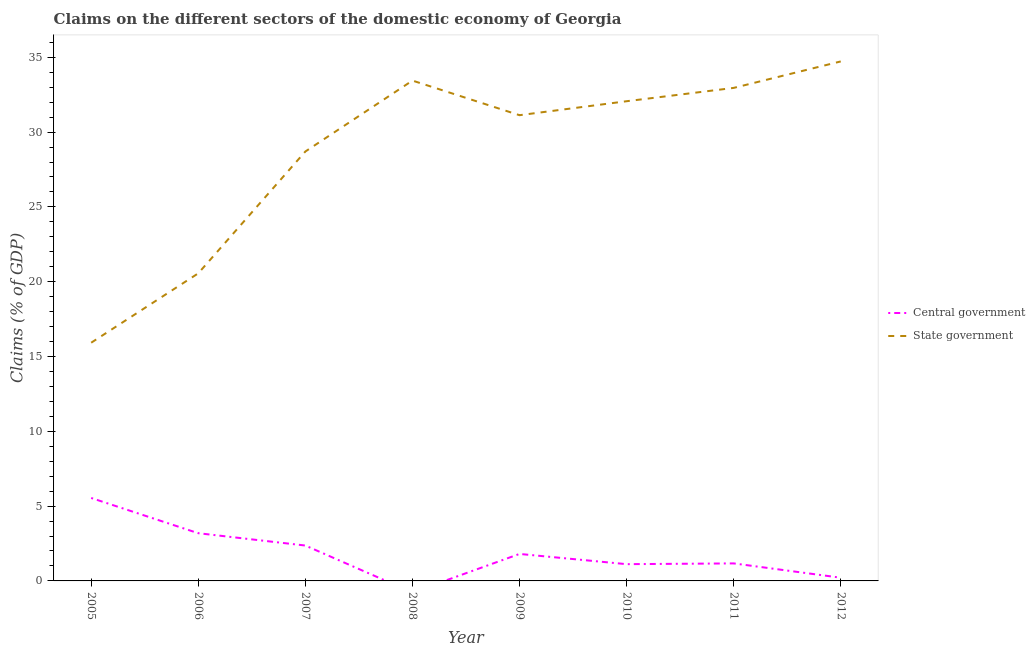How many different coloured lines are there?
Offer a very short reply. 2. Does the line corresponding to claims on central government intersect with the line corresponding to claims on state government?
Provide a succinct answer. No. Is the number of lines equal to the number of legend labels?
Keep it short and to the point. No. What is the claims on state government in 2006?
Keep it short and to the point. 20.56. Across all years, what is the maximum claims on central government?
Your answer should be very brief. 5.54. In which year was the claims on state government maximum?
Provide a short and direct response. 2012. What is the total claims on central government in the graph?
Make the answer very short. 15.41. What is the difference between the claims on central government in 2006 and that in 2010?
Your answer should be compact. 2.07. What is the difference between the claims on central government in 2009 and the claims on state government in 2007?
Make the answer very short. -26.9. What is the average claims on state government per year?
Your answer should be compact. 28.69. In the year 2009, what is the difference between the claims on state government and claims on central government?
Provide a succinct answer. 29.33. In how many years, is the claims on central government greater than 19 %?
Offer a terse response. 0. What is the ratio of the claims on state government in 2005 to that in 2011?
Give a very brief answer. 0.48. Is the difference between the claims on state government in 2006 and 2011 greater than the difference between the claims on central government in 2006 and 2011?
Give a very brief answer. No. What is the difference between the highest and the second highest claims on state government?
Give a very brief answer. 1.28. What is the difference between the highest and the lowest claims on state government?
Keep it short and to the point. 18.8. Does the claims on state government monotonically increase over the years?
Your answer should be compact. No. Is the claims on state government strictly greater than the claims on central government over the years?
Offer a very short reply. Yes. Is the claims on state government strictly less than the claims on central government over the years?
Give a very brief answer. No. How many lines are there?
Give a very brief answer. 2. How many years are there in the graph?
Provide a succinct answer. 8. Does the graph contain any zero values?
Your response must be concise. Yes. Does the graph contain grids?
Make the answer very short. No. How are the legend labels stacked?
Your answer should be very brief. Vertical. What is the title of the graph?
Your response must be concise. Claims on the different sectors of the domestic economy of Georgia. What is the label or title of the Y-axis?
Offer a very short reply. Claims (% of GDP). What is the Claims (% of GDP) in Central government in 2005?
Offer a terse response. 5.54. What is the Claims (% of GDP) in State government in 2005?
Give a very brief answer. 15.92. What is the Claims (% of GDP) of Central government in 2006?
Your answer should be compact. 3.19. What is the Claims (% of GDP) in State government in 2006?
Ensure brevity in your answer.  20.56. What is the Claims (% of GDP) in Central government in 2007?
Keep it short and to the point. 2.37. What is the Claims (% of GDP) of State government in 2007?
Provide a short and direct response. 28.7. What is the Claims (% of GDP) of State government in 2008?
Your answer should be very brief. 33.44. What is the Claims (% of GDP) of Central government in 2009?
Offer a very short reply. 1.8. What is the Claims (% of GDP) of State government in 2009?
Your answer should be very brief. 31.13. What is the Claims (% of GDP) of Central government in 2010?
Provide a succinct answer. 1.12. What is the Claims (% of GDP) of State government in 2010?
Offer a very short reply. 32.06. What is the Claims (% of GDP) of Central government in 2011?
Your answer should be very brief. 1.17. What is the Claims (% of GDP) of State government in 2011?
Keep it short and to the point. 32.95. What is the Claims (% of GDP) in Central government in 2012?
Provide a short and direct response. 0.21. What is the Claims (% of GDP) of State government in 2012?
Ensure brevity in your answer.  34.72. Across all years, what is the maximum Claims (% of GDP) in Central government?
Your response must be concise. 5.54. Across all years, what is the maximum Claims (% of GDP) in State government?
Keep it short and to the point. 34.72. Across all years, what is the minimum Claims (% of GDP) in State government?
Make the answer very short. 15.92. What is the total Claims (% of GDP) of Central government in the graph?
Your response must be concise. 15.41. What is the total Claims (% of GDP) of State government in the graph?
Provide a short and direct response. 229.49. What is the difference between the Claims (% of GDP) in Central government in 2005 and that in 2006?
Provide a short and direct response. 2.35. What is the difference between the Claims (% of GDP) in State government in 2005 and that in 2006?
Offer a very short reply. -4.64. What is the difference between the Claims (% of GDP) of Central government in 2005 and that in 2007?
Give a very brief answer. 3.18. What is the difference between the Claims (% of GDP) of State government in 2005 and that in 2007?
Provide a short and direct response. -12.78. What is the difference between the Claims (% of GDP) of State government in 2005 and that in 2008?
Your answer should be compact. -17.52. What is the difference between the Claims (% of GDP) of Central government in 2005 and that in 2009?
Provide a succinct answer. 3.74. What is the difference between the Claims (% of GDP) in State government in 2005 and that in 2009?
Your response must be concise. -15.21. What is the difference between the Claims (% of GDP) of Central government in 2005 and that in 2010?
Give a very brief answer. 4.42. What is the difference between the Claims (% of GDP) in State government in 2005 and that in 2010?
Make the answer very short. -16.14. What is the difference between the Claims (% of GDP) of Central government in 2005 and that in 2011?
Your answer should be very brief. 4.37. What is the difference between the Claims (% of GDP) in State government in 2005 and that in 2011?
Give a very brief answer. -17.03. What is the difference between the Claims (% of GDP) of Central government in 2005 and that in 2012?
Your answer should be compact. 5.33. What is the difference between the Claims (% of GDP) of State government in 2005 and that in 2012?
Give a very brief answer. -18.8. What is the difference between the Claims (% of GDP) of Central government in 2006 and that in 2007?
Make the answer very short. 0.82. What is the difference between the Claims (% of GDP) of State government in 2006 and that in 2007?
Provide a succinct answer. -8.14. What is the difference between the Claims (% of GDP) in State government in 2006 and that in 2008?
Your response must be concise. -12.88. What is the difference between the Claims (% of GDP) of Central government in 2006 and that in 2009?
Your answer should be compact. 1.39. What is the difference between the Claims (% of GDP) of State government in 2006 and that in 2009?
Give a very brief answer. -10.57. What is the difference between the Claims (% of GDP) of Central government in 2006 and that in 2010?
Keep it short and to the point. 2.07. What is the difference between the Claims (% of GDP) of State government in 2006 and that in 2010?
Provide a succinct answer. -11.5. What is the difference between the Claims (% of GDP) in Central government in 2006 and that in 2011?
Ensure brevity in your answer.  2.02. What is the difference between the Claims (% of GDP) of State government in 2006 and that in 2011?
Ensure brevity in your answer.  -12.39. What is the difference between the Claims (% of GDP) in Central government in 2006 and that in 2012?
Ensure brevity in your answer.  2.97. What is the difference between the Claims (% of GDP) of State government in 2006 and that in 2012?
Offer a terse response. -14.16. What is the difference between the Claims (% of GDP) in State government in 2007 and that in 2008?
Ensure brevity in your answer.  -4.74. What is the difference between the Claims (% of GDP) of Central government in 2007 and that in 2009?
Give a very brief answer. 0.56. What is the difference between the Claims (% of GDP) in State government in 2007 and that in 2009?
Offer a very short reply. -2.43. What is the difference between the Claims (% of GDP) in Central government in 2007 and that in 2010?
Offer a very short reply. 1.25. What is the difference between the Claims (% of GDP) in State government in 2007 and that in 2010?
Your answer should be compact. -3.36. What is the difference between the Claims (% of GDP) of Central government in 2007 and that in 2011?
Your answer should be very brief. 1.19. What is the difference between the Claims (% of GDP) of State government in 2007 and that in 2011?
Your response must be concise. -4.25. What is the difference between the Claims (% of GDP) of Central government in 2007 and that in 2012?
Your answer should be compact. 2.15. What is the difference between the Claims (% of GDP) of State government in 2007 and that in 2012?
Make the answer very short. -6.02. What is the difference between the Claims (% of GDP) of State government in 2008 and that in 2009?
Your response must be concise. 2.31. What is the difference between the Claims (% of GDP) of State government in 2008 and that in 2010?
Keep it short and to the point. 1.38. What is the difference between the Claims (% of GDP) in State government in 2008 and that in 2011?
Offer a very short reply. 0.49. What is the difference between the Claims (% of GDP) of State government in 2008 and that in 2012?
Provide a short and direct response. -1.28. What is the difference between the Claims (% of GDP) of Central government in 2009 and that in 2010?
Ensure brevity in your answer.  0.68. What is the difference between the Claims (% of GDP) in State government in 2009 and that in 2010?
Keep it short and to the point. -0.93. What is the difference between the Claims (% of GDP) in Central government in 2009 and that in 2011?
Offer a very short reply. 0.63. What is the difference between the Claims (% of GDP) in State government in 2009 and that in 2011?
Offer a terse response. -1.82. What is the difference between the Claims (% of GDP) in Central government in 2009 and that in 2012?
Provide a short and direct response. 1.59. What is the difference between the Claims (% of GDP) of State government in 2009 and that in 2012?
Your answer should be compact. -3.59. What is the difference between the Claims (% of GDP) in Central government in 2010 and that in 2011?
Offer a terse response. -0.05. What is the difference between the Claims (% of GDP) in State government in 2010 and that in 2011?
Offer a very short reply. -0.89. What is the difference between the Claims (% of GDP) of Central government in 2010 and that in 2012?
Keep it short and to the point. 0.91. What is the difference between the Claims (% of GDP) of State government in 2010 and that in 2012?
Your answer should be very brief. -2.66. What is the difference between the Claims (% of GDP) of Central government in 2011 and that in 2012?
Offer a very short reply. 0.96. What is the difference between the Claims (% of GDP) of State government in 2011 and that in 2012?
Ensure brevity in your answer.  -1.77. What is the difference between the Claims (% of GDP) of Central government in 2005 and the Claims (% of GDP) of State government in 2006?
Offer a very short reply. -15.02. What is the difference between the Claims (% of GDP) in Central government in 2005 and the Claims (% of GDP) in State government in 2007?
Your response must be concise. -23.16. What is the difference between the Claims (% of GDP) of Central government in 2005 and the Claims (% of GDP) of State government in 2008?
Keep it short and to the point. -27.9. What is the difference between the Claims (% of GDP) in Central government in 2005 and the Claims (% of GDP) in State government in 2009?
Your answer should be very brief. -25.59. What is the difference between the Claims (% of GDP) in Central government in 2005 and the Claims (% of GDP) in State government in 2010?
Provide a short and direct response. -26.52. What is the difference between the Claims (% of GDP) in Central government in 2005 and the Claims (% of GDP) in State government in 2011?
Your answer should be compact. -27.41. What is the difference between the Claims (% of GDP) of Central government in 2005 and the Claims (% of GDP) of State government in 2012?
Ensure brevity in your answer.  -29.18. What is the difference between the Claims (% of GDP) in Central government in 2006 and the Claims (% of GDP) in State government in 2007?
Your answer should be compact. -25.51. What is the difference between the Claims (% of GDP) in Central government in 2006 and the Claims (% of GDP) in State government in 2008?
Offer a terse response. -30.25. What is the difference between the Claims (% of GDP) of Central government in 2006 and the Claims (% of GDP) of State government in 2009?
Your response must be concise. -27.94. What is the difference between the Claims (% of GDP) in Central government in 2006 and the Claims (% of GDP) in State government in 2010?
Keep it short and to the point. -28.87. What is the difference between the Claims (% of GDP) in Central government in 2006 and the Claims (% of GDP) in State government in 2011?
Offer a very short reply. -29.76. What is the difference between the Claims (% of GDP) of Central government in 2006 and the Claims (% of GDP) of State government in 2012?
Provide a succinct answer. -31.53. What is the difference between the Claims (% of GDP) in Central government in 2007 and the Claims (% of GDP) in State government in 2008?
Your response must be concise. -31.08. What is the difference between the Claims (% of GDP) in Central government in 2007 and the Claims (% of GDP) in State government in 2009?
Provide a short and direct response. -28.76. What is the difference between the Claims (% of GDP) of Central government in 2007 and the Claims (% of GDP) of State government in 2010?
Give a very brief answer. -29.7. What is the difference between the Claims (% of GDP) of Central government in 2007 and the Claims (% of GDP) of State government in 2011?
Offer a terse response. -30.59. What is the difference between the Claims (% of GDP) in Central government in 2007 and the Claims (% of GDP) in State government in 2012?
Your answer should be compact. -32.36. What is the difference between the Claims (% of GDP) in Central government in 2009 and the Claims (% of GDP) in State government in 2010?
Give a very brief answer. -30.26. What is the difference between the Claims (% of GDP) of Central government in 2009 and the Claims (% of GDP) of State government in 2011?
Your response must be concise. -31.15. What is the difference between the Claims (% of GDP) of Central government in 2009 and the Claims (% of GDP) of State government in 2012?
Your answer should be very brief. -32.92. What is the difference between the Claims (% of GDP) of Central government in 2010 and the Claims (% of GDP) of State government in 2011?
Make the answer very short. -31.83. What is the difference between the Claims (% of GDP) in Central government in 2010 and the Claims (% of GDP) in State government in 2012?
Offer a very short reply. -33.6. What is the difference between the Claims (% of GDP) of Central government in 2011 and the Claims (% of GDP) of State government in 2012?
Keep it short and to the point. -33.55. What is the average Claims (% of GDP) of Central government per year?
Keep it short and to the point. 1.93. What is the average Claims (% of GDP) of State government per year?
Keep it short and to the point. 28.69. In the year 2005, what is the difference between the Claims (% of GDP) of Central government and Claims (% of GDP) of State government?
Your answer should be compact. -10.38. In the year 2006, what is the difference between the Claims (% of GDP) in Central government and Claims (% of GDP) in State government?
Offer a terse response. -17.37. In the year 2007, what is the difference between the Claims (% of GDP) in Central government and Claims (% of GDP) in State government?
Your response must be concise. -26.34. In the year 2009, what is the difference between the Claims (% of GDP) in Central government and Claims (% of GDP) in State government?
Your response must be concise. -29.33. In the year 2010, what is the difference between the Claims (% of GDP) in Central government and Claims (% of GDP) in State government?
Keep it short and to the point. -30.94. In the year 2011, what is the difference between the Claims (% of GDP) in Central government and Claims (% of GDP) in State government?
Provide a short and direct response. -31.78. In the year 2012, what is the difference between the Claims (% of GDP) in Central government and Claims (% of GDP) in State government?
Your answer should be compact. -34.51. What is the ratio of the Claims (% of GDP) of Central government in 2005 to that in 2006?
Offer a terse response. 1.74. What is the ratio of the Claims (% of GDP) in State government in 2005 to that in 2006?
Your answer should be compact. 0.77. What is the ratio of the Claims (% of GDP) in Central government in 2005 to that in 2007?
Provide a short and direct response. 2.34. What is the ratio of the Claims (% of GDP) of State government in 2005 to that in 2007?
Offer a terse response. 0.55. What is the ratio of the Claims (% of GDP) in State government in 2005 to that in 2008?
Make the answer very short. 0.48. What is the ratio of the Claims (% of GDP) in Central government in 2005 to that in 2009?
Keep it short and to the point. 3.07. What is the ratio of the Claims (% of GDP) in State government in 2005 to that in 2009?
Your answer should be very brief. 0.51. What is the ratio of the Claims (% of GDP) of Central government in 2005 to that in 2010?
Make the answer very short. 4.95. What is the ratio of the Claims (% of GDP) of State government in 2005 to that in 2010?
Offer a terse response. 0.5. What is the ratio of the Claims (% of GDP) of Central government in 2005 to that in 2011?
Keep it short and to the point. 4.73. What is the ratio of the Claims (% of GDP) in State government in 2005 to that in 2011?
Provide a short and direct response. 0.48. What is the ratio of the Claims (% of GDP) of Central government in 2005 to that in 2012?
Provide a short and direct response. 25.8. What is the ratio of the Claims (% of GDP) of State government in 2005 to that in 2012?
Offer a terse response. 0.46. What is the ratio of the Claims (% of GDP) of Central government in 2006 to that in 2007?
Your response must be concise. 1.35. What is the ratio of the Claims (% of GDP) in State government in 2006 to that in 2007?
Offer a terse response. 0.72. What is the ratio of the Claims (% of GDP) in State government in 2006 to that in 2008?
Make the answer very short. 0.61. What is the ratio of the Claims (% of GDP) of Central government in 2006 to that in 2009?
Your response must be concise. 1.77. What is the ratio of the Claims (% of GDP) in State government in 2006 to that in 2009?
Give a very brief answer. 0.66. What is the ratio of the Claims (% of GDP) of Central government in 2006 to that in 2010?
Keep it short and to the point. 2.85. What is the ratio of the Claims (% of GDP) in State government in 2006 to that in 2010?
Your answer should be compact. 0.64. What is the ratio of the Claims (% of GDP) in Central government in 2006 to that in 2011?
Provide a short and direct response. 2.72. What is the ratio of the Claims (% of GDP) in State government in 2006 to that in 2011?
Keep it short and to the point. 0.62. What is the ratio of the Claims (% of GDP) of Central government in 2006 to that in 2012?
Your response must be concise. 14.84. What is the ratio of the Claims (% of GDP) in State government in 2006 to that in 2012?
Provide a succinct answer. 0.59. What is the ratio of the Claims (% of GDP) in State government in 2007 to that in 2008?
Ensure brevity in your answer.  0.86. What is the ratio of the Claims (% of GDP) in Central government in 2007 to that in 2009?
Ensure brevity in your answer.  1.31. What is the ratio of the Claims (% of GDP) in State government in 2007 to that in 2009?
Your response must be concise. 0.92. What is the ratio of the Claims (% of GDP) in Central government in 2007 to that in 2010?
Provide a short and direct response. 2.11. What is the ratio of the Claims (% of GDP) in State government in 2007 to that in 2010?
Keep it short and to the point. 0.9. What is the ratio of the Claims (% of GDP) of Central government in 2007 to that in 2011?
Your response must be concise. 2.02. What is the ratio of the Claims (% of GDP) in State government in 2007 to that in 2011?
Your answer should be compact. 0.87. What is the ratio of the Claims (% of GDP) in Central government in 2007 to that in 2012?
Provide a short and direct response. 11.01. What is the ratio of the Claims (% of GDP) in State government in 2007 to that in 2012?
Offer a very short reply. 0.83. What is the ratio of the Claims (% of GDP) in State government in 2008 to that in 2009?
Your response must be concise. 1.07. What is the ratio of the Claims (% of GDP) in State government in 2008 to that in 2010?
Your response must be concise. 1.04. What is the ratio of the Claims (% of GDP) in State government in 2008 to that in 2011?
Provide a short and direct response. 1.01. What is the ratio of the Claims (% of GDP) of State government in 2008 to that in 2012?
Keep it short and to the point. 0.96. What is the ratio of the Claims (% of GDP) of Central government in 2009 to that in 2010?
Your response must be concise. 1.61. What is the ratio of the Claims (% of GDP) in State government in 2009 to that in 2010?
Keep it short and to the point. 0.97. What is the ratio of the Claims (% of GDP) in Central government in 2009 to that in 2011?
Your response must be concise. 1.54. What is the ratio of the Claims (% of GDP) of State government in 2009 to that in 2011?
Provide a succinct answer. 0.94. What is the ratio of the Claims (% of GDP) of Central government in 2009 to that in 2012?
Your answer should be very brief. 8.39. What is the ratio of the Claims (% of GDP) of State government in 2009 to that in 2012?
Your response must be concise. 0.9. What is the ratio of the Claims (% of GDP) in Central government in 2010 to that in 2011?
Offer a very short reply. 0.96. What is the ratio of the Claims (% of GDP) in State government in 2010 to that in 2011?
Offer a terse response. 0.97. What is the ratio of the Claims (% of GDP) in Central government in 2010 to that in 2012?
Offer a very short reply. 5.21. What is the ratio of the Claims (% of GDP) in State government in 2010 to that in 2012?
Offer a very short reply. 0.92. What is the ratio of the Claims (% of GDP) in Central government in 2011 to that in 2012?
Make the answer very short. 5.45. What is the ratio of the Claims (% of GDP) of State government in 2011 to that in 2012?
Your answer should be compact. 0.95. What is the difference between the highest and the second highest Claims (% of GDP) in Central government?
Your answer should be very brief. 2.35. What is the difference between the highest and the second highest Claims (% of GDP) of State government?
Provide a short and direct response. 1.28. What is the difference between the highest and the lowest Claims (% of GDP) of Central government?
Provide a succinct answer. 5.54. What is the difference between the highest and the lowest Claims (% of GDP) in State government?
Ensure brevity in your answer.  18.8. 